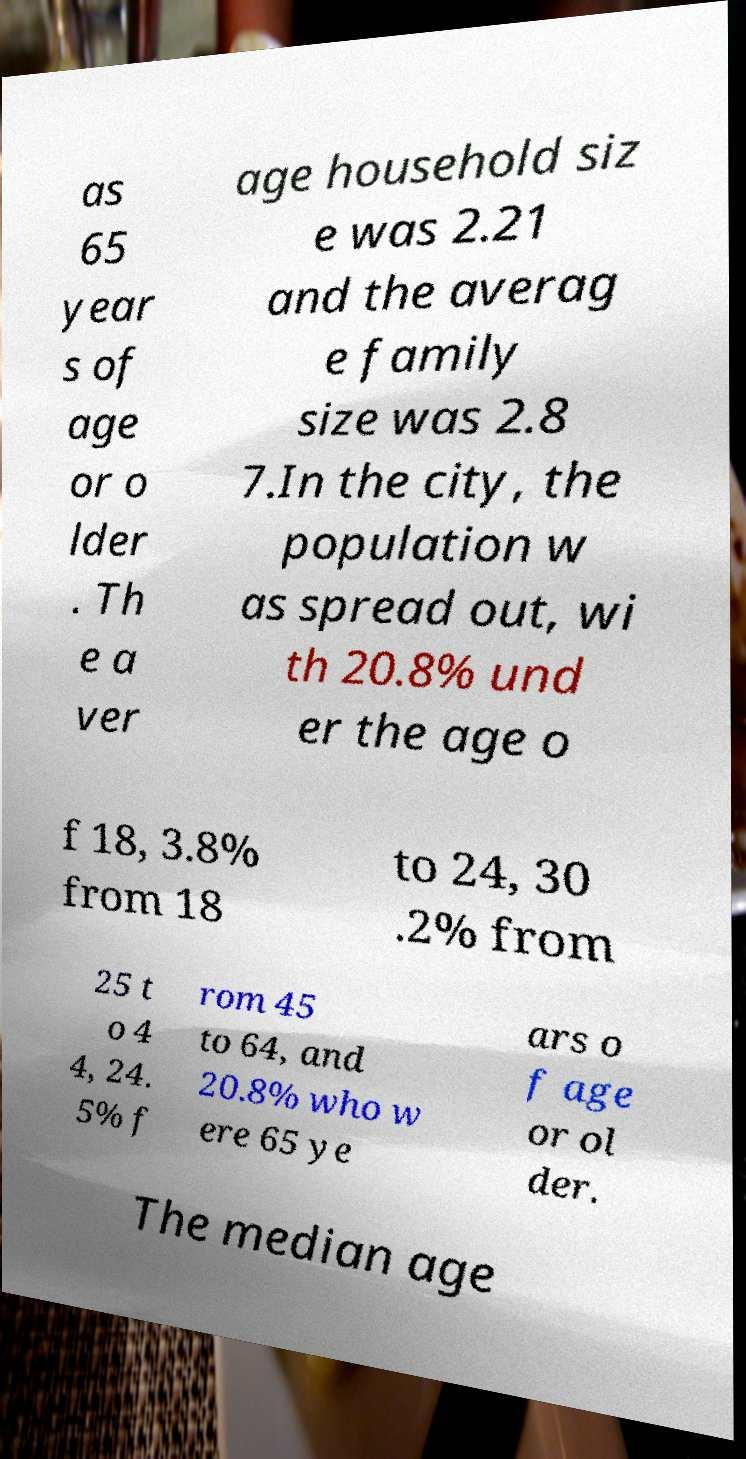Could you extract and type out the text from this image? as 65 year s of age or o lder . Th e a ver age household siz e was 2.21 and the averag e family size was 2.8 7.In the city, the population w as spread out, wi th 20.8% und er the age o f 18, 3.8% from 18 to 24, 30 .2% from 25 t o 4 4, 24. 5% f rom 45 to 64, and 20.8% who w ere 65 ye ars o f age or ol der. The median age 